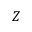<formula> <loc_0><loc_0><loc_500><loc_500>Z</formula> 